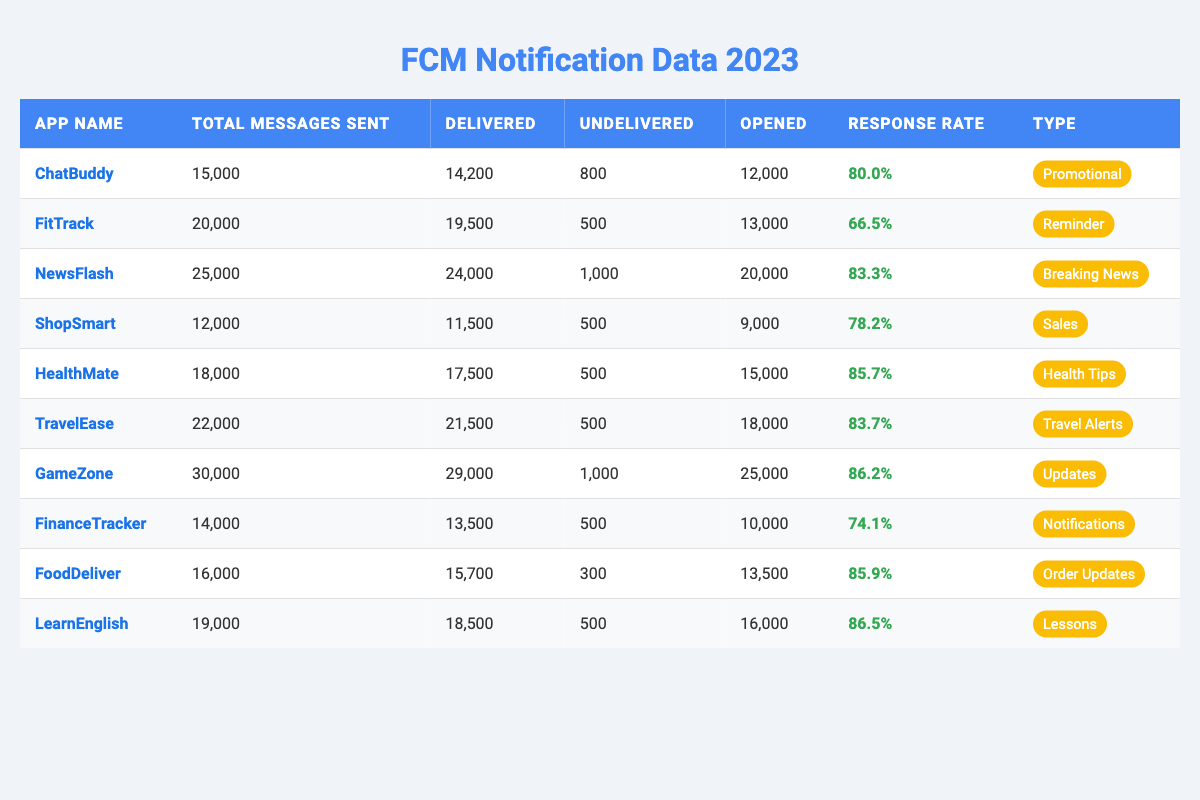What is the response rate of the app LearnEnglish? Looking at the row for LearnEnglish, the response rate is listed as 86.5%.
Answer: 86.5% Which app had the highest number of total messages sent? The app with the highest total messages sent is GameZone, with 30,000 messages.
Answer: GameZone How many messages were delivered by the app NewsFlash? Referring to the NewsFlash row, it shows that 24,000 messages were delivered.
Answer: 24,000 What percentage of messages were opened by users for HealthMate? The opened messages for HealthMate are 15,000 out of 17,500 delivered messages, which gives a percentage of (15,000/17,500)*100 = 85.7%.
Answer: 85.7% How many more messages were opened than delivered for the app ShopSmart? For ShopSmart, 9,000 messages were opened while 11,500 were delivered. The difference is 9,000 - 11,500 = -2,500, which indicates that opened messages are less than delivered.
Answer: -2,500 Which app has the lowest delivery rate? The delivery rate can be calculated for each app as Delivered/Total Messages Sent. For FitTrack, the rate is 19,500/20,000 = 0.975 or 97.5%. Comparing all, FinanceTracker has the lowest at 13,500/14,000 = 0.964 or 96.4%.
Answer: FinanceTracker What is the average response rate across all apps? Summing the response rates: (0.8 + 0.665 + 0.833 + 0.782 + 0.857 + 0.837 + 0.862 + 0.741 + 0.859 + 0.865) = 8.295. There are 10 apps, so the average is 8.295/10 = 0.8295, or 82.95%.
Answer: 82.95% Did any app have a response rate equal to or greater than 85%? Checking the values, the response rates for HealthMate (85.7%), TravelEase (83.7%), GameZone (86.2%), FoodDeliver (85.9%), and LearnEnglish (86.5%) are all equal to or above 85%.
Answer: Yes Which app had the highest number of undelivered messages? The highest undelivered messages listed is by ChatBuddy with 800 messages undelivered, compared to others.
Answer: ChatBuddy If we combine the total messages sent for ChatBuddy and ShopSmart, what is the total? Adding the total messages for both apps: ChatBuddy (15,000) + ShopSmart (12,000) = 27,000 messages.
Answer: 27,000 